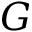<formula> <loc_0><loc_0><loc_500><loc_500>G</formula> 